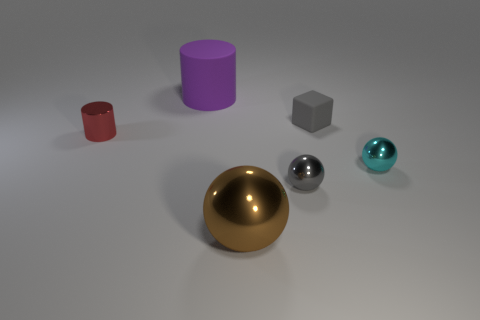Add 2 metal objects. How many objects exist? 8 Subtract all cubes. How many objects are left? 5 Subtract 1 gray blocks. How many objects are left? 5 Subtract all gray things. Subtract all gray things. How many objects are left? 2 Add 5 tiny metallic balls. How many tiny metallic balls are left? 7 Add 5 cyan balls. How many cyan balls exist? 6 